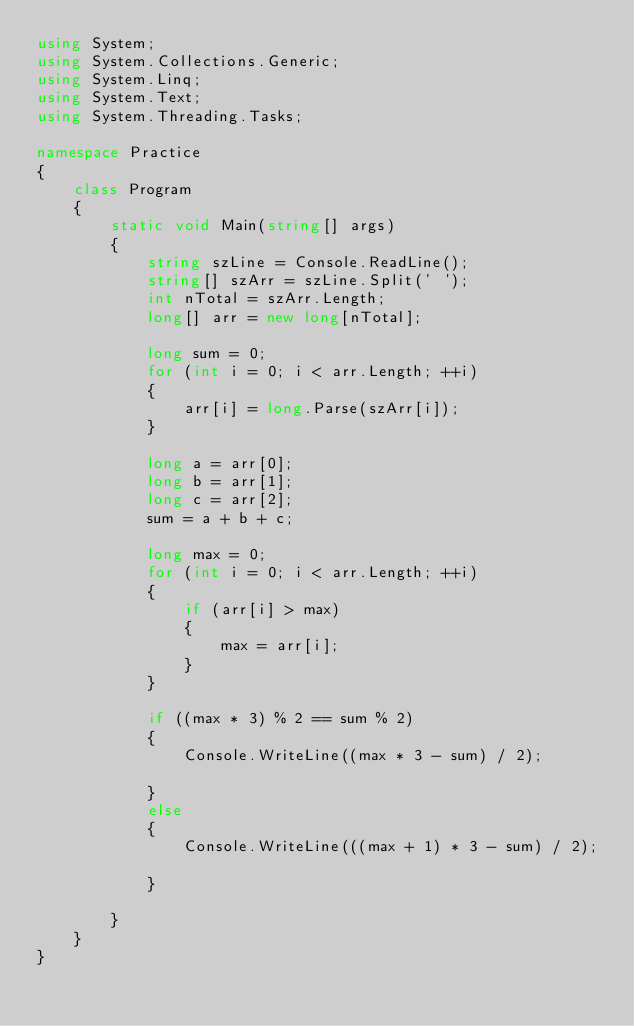<code> <loc_0><loc_0><loc_500><loc_500><_C#_>using System;
using System.Collections.Generic;
using System.Linq;
using System.Text;
using System.Threading.Tasks;

namespace Practice
{
    class Program
    {
        static void Main(string[] args)
        {
            string szLine = Console.ReadLine();
            string[] szArr = szLine.Split(' ');
            int nTotal = szArr.Length;
            long[] arr = new long[nTotal];

            long sum = 0;
            for (int i = 0; i < arr.Length; ++i)
            {
                arr[i] = long.Parse(szArr[i]);
            }

            long a = arr[0];
            long b = arr[1];
            long c = arr[2];
            sum = a + b + c;

            long max = 0;
            for (int i = 0; i < arr.Length; ++i)
            {
                if (arr[i] > max)
                {
                    max = arr[i];
                }
            }

            if ((max * 3) % 2 == sum % 2)
            {
                Console.WriteLine((max * 3 - sum) / 2);

            }
            else
            {
                Console.WriteLine(((max + 1) * 3 - sum) / 2);

            }

        }
    }
}
</code> 